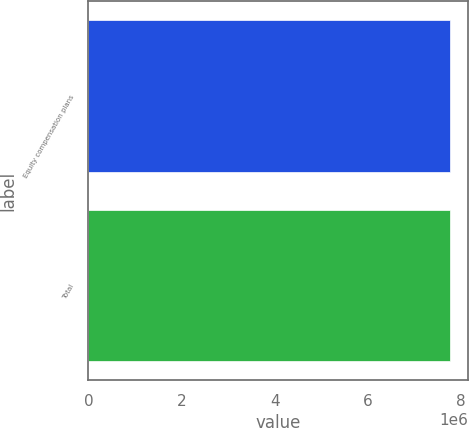Convert chart. <chart><loc_0><loc_0><loc_500><loc_500><bar_chart><fcel>Equity compensation plans<fcel>Total<nl><fcel>7.77248e+06<fcel>7.77248e+06<nl></chart> 